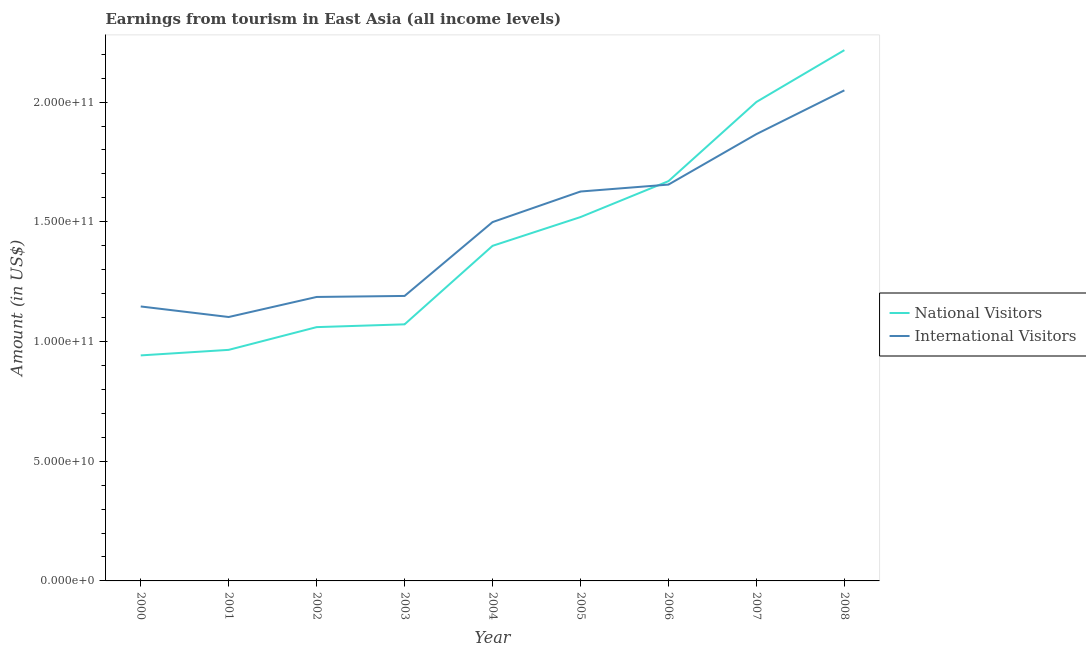How many different coloured lines are there?
Give a very brief answer. 2. Does the line corresponding to amount earned from international visitors intersect with the line corresponding to amount earned from national visitors?
Your answer should be compact. Yes. What is the amount earned from national visitors in 2006?
Make the answer very short. 1.67e+11. Across all years, what is the maximum amount earned from international visitors?
Your answer should be very brief. 2.05e+11. Across all years, what is the minimum amount earned from international visitors?
Give a very brief answer. 1.10e+11. In which year was the amount earned from international visitors minimum?
Offer a very short reply. 2001. What is the total amount earned from national visitors in the graph?
Ensure brevity in your answer.  1.28e+12. What is the difference between the amount earned from international visitors in 2005 and that in 2006?
Ensure brevity in your answer.  -2.89e+09. What is the difference between the amount earned from national visitors in 2000 and the amount earned from international visitors in 2001?
Your answer should be very brief. -1.60e+1. What is the average amount earned from international visitors per year?
Your answer should be compact. 1.48e+11. In the year 2006, what is the difference between the amount earned from national visitors and amount earned from international visitors?
Offer a terse response. 1.44e+09. In how many years, is the amount earned from national visitors greater than 200000000000 US$?
Your response must be concise. 2. What is the ratio of the amount earned from national visitors in 2002 to that in 2003?
Keep it short and to the point. 0.99. What is the difference between the highest and the second highest amount earned from national visitors?
Your response must be concise. 2.16e+1. What is the difference between the highest and the lowest amount earned from international visitors?
Give a very brief answer. 9.47e+1. In how many years, is the amount earned from international visitors greater than the average amount earned from international visitors taken over all years?
Your answer should be very brief. 5. Does the amount earned from international visitors monotonically increase over the years?
Offer a very short reply. No. Is the amount earned from national visitors strictly less than the amount earned from international visitors over the years?
Your answer should be very brief. No. How many lines are there?
Keep it short and to the point. 2. How many years are there in the graph?
Offer a terse response. 9. Does the graph contain grids?
Provide a succinct answer. No. Where does the legend appear in the graph?
Keep it short and to the point. Center right. How are the legend labels stacked?
Offer a terse response. Vertical. What is the title of the graph?
Make the answer very short. Earnings from tourism in East Asia (all income levels). Does "Techinal cooperation" appear as one of the legend labels in the graph?
Your answer should be compact. No. What is the label or title of the X-axis?
Offer a very short reply. Year. What is the Amount (in US$) in National Visitors in 2000?
Make the answer very short. 9.42e+1. What is the Amount (in US$) in International Visitors in 2000?
Offer a very short reply. 1.15e+11. What is the Amount (in US$) of National Visitors in 2001?
Offer a terse response. 9.65e+1. What is the Amount (in US$) in International Visitors in 2001?
Your answer should be compact. 1.10e+11. What is the Amount (in US$) in National Visitors in 2002?
Make the answer very short. 1.06e+11. What is the Amount (in US$) of International Visitors in 2002?
Your answer should be very brief. 1.19e+11. What is the Amount (in US$) of National Visitors in 2003?
Offer a terse response. 1.07e+11. What is the Amount (in US$) of International Visitors in 2003?
Keep it short and to the point. 1.19e+11. What is the Amount (in US$) in National Visitors in 2004?
Provide a succinct answer. 1.40e+11. What is the Amount (in US$) of International Visitors in 2004?
Your response must be concise. 1.50e+11. What is the Amount (in US$) of National Visitors in 2005?
Provide a short and direct response. 1.52e+11. What is the Amount (in US$) of International Visitors in 2005?
Give a very brief answer. 1.63e+11. What is the Amount (in US$) of National Visitors in 2006?
Your answer should be very brief. 1.67e+11. What is the Amount (in US$) of International Visitors in 2006?
Provide a short and direct response. 1.66e+11. What is the Amount (in US$) in National Visitors in 2007?
Offer a very short reply. 2.00e+11. What is the Amount (in US$) of International Visitors in 2007?
Ensure brevity in your answer.  1.87e+11. What is the Amount (in US$) of National Visitors in 2008?
Your answer should be very brief. 2.22e+11. What is the Amount (in US$) of International Visitors in 2008?
Provide a short and direct response. 2.05e+11. Across all years, what is the maximum Amount (in US$) of National Visitors?
Keep it short and to the point. 2.22e+11. Across all years, what is the maximum Amount (in US$) of International Visitors?
Your answer should be compact. 2.05e+11. Across all years, what is the minimum Amount (in US$) in National Visitors?
Your answer should be very brief. 9.42e+1. Across all years, what is the minimum Amount (in US$) in International Visitors?
Offer a terse response. 1.10e+11. What is the total Amount (in US$) of National Visitors in the graph?
Provide a succinct answer. 1.28e+12. What is the total Amount (in US$) of International Visitors in the graph?
Your answer should be very brief. 1.33e+12. What is the difference between the Amount (in US$) in National Visitors in 2000 and that in 2001?
Give a very brief answer. -2.31e+09. What is the difference between the Amount (in US$) in International Visitors in 2000 and that in 2001?
Provide a short and direct response. 4.40e+09. What is the difference between the Amount (in US$) in National Visitors in 2000 and that in 2002?
Your answer should be very brief. -1.18e+1. What is the difference between the Amount (in US$) of International Visitors in 2000 and that in 2002?
Your answer should be compact. -3.97e+09. What is the difference between the Amount (in US$) of National Visitors in 2000 and that in 2003?
Your answer should be very brief. -1.30e+1. What is the difference between the Amount (in US$) in International Visitors in 2000 and that in 2003?
Ensure brevity in your answer.  -4.40e+09. What is the difference between the Amount (in US$) in National Visitors in 2000 and that in 2004?
Keep it short and to the point. -4.58e+1. What is the difference between the Amount (in US$) in International Visitors in 2000 and that in 2004?
Provide a succinct answer. -3.52e+1. What is the difference between the Amount (in US$) in National Visitors in 2000 and that in 2005?
Ensure brevity in your answer.  -5.78e+1. What is the difference between the Amount (in US$) of International Visitors in 2000 and that in 2005?
Provide a short and direct response. -4.80e+1. What is the difference between the Amount (in US$) in National Visitors in 2000 and that in 2006?
Ensure brevity in your answer.  -7.28e+1. What is the difference between the Amount (in US$) of International Visitors in 2000 and that in 2006?
Make the answer very short. -5.09e+1. What is the difference between the Amount (in US$) in National Visitors in 2000 and that in 2007?
Provide a succinct answer. -1.06e+11. What is the difference between the Amount (in US$) of International Visitors in 2000 and that in 2007?
Offer a terse response. -7.20e+1. What is the difference between the Amount (in US$) in National Visitors in 2000 and that in 2008?
Provide a succinct answer. -1.27e+11. What is the difference between the Amount (in US$) of International Visitors in 2000 and that in 2008?
Provide a succinct answer. -9.03e+1. What is the difference between the Amount (in US$) in National Visitors in 2001 and that in 2002?
Provide a succinct answer. -9.50e+09. What is the difference between the Amount (in US$) in International Visitors in 2001 and that in 2002?
Make the answer very short. -8.38e+09. What is the difference between the Amount (in US$) in National Visitors in 2001 and that in 2003?
Your response must be concise. -1.07e+1. What is the difference between the Amount (in US$) of International Visitors in 2001 and that in 2003?
Ensure brevity in your answer.  -8.80e+09. What is the difference between the Amount (in US$) of National Visitors in 2001 and that in 2004?
Ensure brevity in your answer.  -4.35e+1. What is the difference between the Amount (in US$) of International Visitors in 2001 and that in 2004?
Give a very brief answer. -3.96e+1. What is the difference between the Amount (in US$) of National Visitors in 2001 and that in 2005?
Offer a terse response. -5.55e+1. What is the difference between the Amount (in US$) of International Visitors in 2001 and that in 2005?
Your answer should be compact. -5.24e+1. What is the difference between the Amount (in US$) of National Visitors in 2001 and that in 2006?
Your answer should be very brief. -7.05e+1. What is the difference between the Amount (in US$) of International Visitors in 2001 and that in 2006?
Keep it short and to the point. -5.53e+1. What is the difference between the Amount (in US$) of National Visitors in 2001 and that in 2007?
Make the answer very short. -1.04e+11. What is the difference between the Amount (in US$) of International Visitors in 2001 and that in 2007?
Your answer should be compact. -7.64e+1. What is the difference between the Amount (in US$) in National Visitors in 2001 and that in 2008?
Make the answer very short. -1.25e+11. What is the difference between the Amount (in US$) of International Visitors in 2001 and that in 2008?
Your answer should be very brief. -9.47e+1. What is the difference between the Amount (in US$) of National Visitors in 2002 and that in 2003?
Make the answer very short. -1.17e+09. What is the difference between the Amount (in US$) in International Visitors in 2002 and that in 2003?
Offer a terse response. -4.22e+08. What is the difference between the Amount (in US$) in National Visitors in 2002 and that in 2004?
Ensure brevity in your answer.  -3.40e+1. What is the difference between the Amount (in US$) of International Visitors in 2002 and that in 2004?
Keep it short and to the point. -3.13e+1. What is the difference between the Amount (in US$) of National Visitors in 2002 and that in 2005?
Give a very brief answer. -4.60e+1. What is the difference between the Amount (in US$) of International Visitors in 2002 and that in 2005?
Your answer should be compact. -4.40e+1. What is the difference between the Amount (in US$) in National Visitors in 2002 and that in 2006?
Keep it short and to the point. -6.10e+1. What is the difference between the Amount (in US$) in International Visitors in 2002 and that in 2006?
Make the answer very short. -4.69e+1. What is the difference between the Amount (in US$) of National Visitors in 2002 and that in 2007?
Ensure brevity in your answer.  -9.40e+1. What is the difference between the Amount (in US$) of International Visitors in 2002 and that in 2007?
Provide a short and direct response. -6.80e+1. What is the difference between the Amount (in US$) of National Visitors in 2002 and that in 2008?
Give a very brief answer. -1.16e+11. What is the difference between the Amount (in US$) of International Visitors in 2002 and that in 2008?
Give a very brief answer. -8.63e+1. What is the difference between the Amount (in US$) of National Visitors in 2003 and that in 2004?
Provide a short and direct response. -3.28e+1. What is the difference between the Amount (in US$) in International Visitors in 2003 and that in 2004?
Make the answer very short. -3.08e+1. What is the difference between the Amount (in US$) in National Visitors in 2003 and that in 2005?
Make the answer very short. -4.48e+1. What is the difference between the Amount (in US$) of International Visitors in 2003 and that in 2005?
Make the answer very short. -4.36e+1. What is the difference between the Amount (in US$) of National Visitors in 2003 and that in 2006?
Your response must be concise. -5.98e+1. What is the difference between the Amount (in US$) in International Visitors in 2003 and that in 2006?
Your response must be concise. -4.65e+1. What is the difference between the Amount (in US$) of National Visitors in 2003 and that in 2007?
Offer a very short reply. -9.29e+1. What is the difference between the Amount (in US$) of International Visitors in 2003 and that in 2007?
Offer a very short reply. -6.76e+1. What is the difference between the Amount (in US$) of National Visitors in 2003 and that in 2008?
Offer a terse response. -1.15e+11. What is the difference between the Amount (in US$) in International Visitors in 2003 and that in 2008?
Give a very brief answer. -8.59e+1. What is the difference between the Amount (in US$) of National Visitors in 2004 and that in 2005?
Offer a very short reply. -1.20e+1. What is the difference between the Amount (in US$) in International Visitors in 2004 and that in 2005?
Your answer should be compact. -1.28e+1. What is the difference between the Amount (in US$) of National Visitors in 2004 and that in 2006?
Make the answer very short. -2.70e+1. What is the difference between the Amount (in US$) of International Visitors in 2004 and that in 2006?
Your answer should be very brief. -1.57e+1. What is the difference between the Amount (in US$) of National Visitors in 2004 and that in 2007?
Make the answer very short. -6.01e+1. What is the difference between the Amount (in US$) in International Visitors in 2004 and that in 2007?
Offer a very short reply. -3.67e+1. What is the difference between the Amount (in US$) of National Visitors in 2004 and that in 2008?
Make the answer very short. -8.17e+1. What is the difference between the Amount (in US$) of International Visitors in 2004 and that in 2008?
Offer a terse response. -5.50e+1. What is the difference between the Amount (in US$) in National Visitors in 2005 and that in 2006?
Provide a succinct answer. -1.50e+1. What is the difference between the Amount (in US$) of International Visitors in 2005 and that in 2006?
Offer a very short reply. -2.89e+09. What is the difference between the Amount (in US$) of National Visitors in 2005 and that in 2007?
Your answer should be very brief. -4.81e+1. What is the difference between the Amount (in US$) of International Visitors in 2005 and that in 2007?
Your response must be concise. -2.40e+1. What is the difference between the Amount (in US$) of National Visitors in 2005 and that in 2008?
Keep it short and to the point. -6.97e+1. What is the difference between the Amount (in US$) in International Visitors in 2005 and that in 2008?
Offer a terse response. -4.23e+1. What is the difference between the Amount (in US$) in National Visitors in 2006 and that in 2007?
Make the answer very short. -3.31e+1. What is the difference between the Amount (in US$) in International Visitors in 2006 and that in 2007?
Provide a short and direct response. -2.11e+1. What is the difference between the Amount (in US$) of National Visitors in 2006 and that in 2008?
Keep it short and to the point. -5.47e+1. What is the difference between the Amount (in US$) of International Visitors in 2006 and that in 2008?
Your answer should be very brief. -3.94e+1. What is the difference between the Amount (in US$) in National Visitors in 2007 and that in 2008?
Provide a succinct answer. -2.16e+1. What is the difference between the Amount (in US$) in International Visitors in 2007 and that in 2008?
Offer a terse response. -1.83e+1. What is the difference between the Amount (in US$) of National Visitors in 2000 and the Amount (in US$) of International Visitors in 2001?
Give a very brief answer. -1.60e+1. What is the difference between the Amount (in US$) of National Visitors in 2000 and the Amount (in US$) of International Visitors in 2002?
Offer a terse response. -2.44e+1. What is the difference between the Amount (in US$) in National Visitors in 2000 and the Amount (in US$) in International Visitors in 2003?
Keep it short and to the point. -2.48e+1. What is the difference between the Amount (in US$) in National Visitors in 2000 and the Amount (in US$) in International Visitors in 2004?
Your response must be concise. -5.57e+1. What is the difference between the Amount (in US$) of National Visitors in 2000 and the Amount (in US$) of International Visitors in 2005?
Your response must be concise. -6.84e+1. What is the difference between the Amount (in US$) of National Visitors in 2000 and the Amount (in US$) of International Visitors in 2006?
Make the answer very short. -7.13e+1. What is the difference between the Amount (in US$) of National Visitors in 2000 and the Amount (in US$) of International Visitors in 2007?
Your answer should be very brief. -9.24e+1. What is the difference between the Amount (in US$) of National Visitors in 2000 and the Amount (in US$) of International Visitors in 2008?
Make the answer very short. -1.11e+11. What is the difference between the Amount (in US$) in National Visitors in 2001 and the Amount (in US$) in International Visitors in 2002?
Make the answer very short. -2.21e+1. What is the difference between the Amount (in US$) of National Visitors in 2001 and the Amount (in US$) of International Visitors in 2003?
Ensure brevity in your answer.  -2.25e+1. What is the difference between the Amount (in US$) in National Visitors in 2001 and the Amount (in US$) in International Visitors in 2004?
Provide a short and direct response. -5.34e+1. What is the difference between the Amount (in US$) in National Visitors in 2001 and the Amount (in US$) in International Visitors in 2005?
Offer a terse response. -6.61e+1. What is the difference between the Amount (in US$) in National Visitors in 2001 and the Amount (in US$) in International Visitors in 2006?
Offer a very short reply. -6.90e+1. What is the difference between the Amount (in US$) of National Visitors in 2001 and the Amount (in US$) of International Visitors in 2007?
Your answer should be compact. -9.01e+1. What is the difference between the Amount (in US$) in National Visitors in 2001 and the Amount (in US$) in International Visitors in 2008?
Your answer should be compact. -1.08e+11. What is the difference between the Amount (in US$) of National Visitors in 2002 and the Amount (in US$) of International Visitors in 2003?
Your response must be concise. -1.30e+1. What is the difference between the Amount (in US$) in National Visitors in 2002 and the Amount (in US$) in International Visitors in 2004?
Ensure brevity in your answer.  -4.39e+1. What is the difference between the Amount (in US$) in National Visitors in 2002 and the Amount (in US$) in International Visitors in 2005?
Your answer should be very brief. -5.66e+1. What is the difference between the Amount (in US$) of National Visitors in 2002 and the Amount (in US$) of International Visitors in 2006?
Provide a short and direct response. -5.95e+1. What is the difference between the Amount (in US$) of National Visitors in 2002 and the Amount (in US$) of International Visitors in 2007?
Your response must be concise. -8.06e+1. What is the difference between the Amount (in US$) of National Visitors in 2002 and the Amount (in US$) of International Visitors in 2008?
Ensure brevity in your answer.  -9.89e+1. What is the difference between the Amount (in US$) of National Visitors in 2003 and the Amount (in US$) of International Visitors in 2004?
Ensure brevity in your answer.  -4.27e+1. What is the difference between the Amount (in US$) of National Visitors in 2003 and the Amount (in US$) of International Visitors in 2005?
Keep it short and to the point. -5.55e+1. What is the difference between the Amount (in US$) of National Visitors in 2003 and the Amount (in US$) of International Visitors in 2006?
Provide a succinct answer. -5.84e+1. What is the difference between the Amount (in US$) of National Visitors in 2003 and the Amount (in US$) of International Visitors in 2007?
Your response must be concise. -7.94e+1. What is the difference between the Amount (in US$) of National Visitors in 2003 and the Amount (in US$) of International Visitors in 2008?
Provide a succinct answer. -9.77e+1. What is the difference between the Amount (in US$) in National Visitors in 2004 and the Amount (in US$) in International Visitors in 2005?
Give a very brief answer. -2.27e+1. What is the difference between the Amount (in US$) of National Visitors in 2004 and the Amount (in US$) of International Visitors in 2006?
Your answer should be compact. -2.56e+1. What is the difference between the Amount (in US$) of National Visitors in 2004 and the Amount (in US$) of International Visitors in 2007?
Make the answer very short. -4.67e+1. What is the difference between the Amount (in US$) of National Visitors in 2004 and the Amount (in US$) of International Visitors in 2008?
Provide a short and direct response. -6.49e+1. What is the difference between the Amount (in US$) in National Visitors in 2005 and the Amount (in US$) in International Visitors in 2006?
Provide a short and direct response. -1.36e+1. What is the difference between the Amount (in US$) of National Visitors in 2005 and the Amount (in US$) of International Visitors in 2007?
Your response must be concise. -3.47e+1. What is the difference between the Amount (in US$) in National Visitors in 2005 and the Amount (in US$) in International Visitors in 2008?
Provide a short and direct response. -5.29e+1. What is the difference between the Amount (in US$) in National Visitors in 2006 and the Amount (in US$) in International Visitors in 2007?
Provide a succinct answer. -1.96e+1. What is the difference between the Amount (in US$) in National Visitors in 2006 and the Amount (in US$) in International Visitors in 2008?
Provide a succinct answer. -3.79e+1. What is the difference between the Amount (in US$) of National Visitors in 2007 and the Amount (in US$) of International Visitors in 2008?
Provide a short and direct response. -4.85e+09. What is the average Amount (in US$) in National Visitors per year?
Give a very brief answer. 1.43e+11. What is the average Amount (in US$) of International Visitors per year?
Give a very brief answer. 1.48e+11. In the year 2000, what is the difference between the Amount (in US$) in National Visitors and Amount (in US$) in International Visitors?
Offer a terse response. -2.04e+1. In the year 2001, what is the difference between the Amount (in US$) of National Visitors and Amount (in US$) of International Visitors?
Give a very brief answer. -1.37e+1. In the year 2002, what is the difference between the Amount (in US$) of National Visitors and Amount (in US$) of International Visitors?
Keep it short and to the point. -1.26e+1. In the year 2003, what is the difference between the Amount (in US$) in National Visitors and Amount (in US$) in International Visitors?
Make the answer very short. -1.19e+1. In the year 2004, what is the difference between the Amount (in US$) in National Visitors and Amount (in US$) in International Visitors?
Offer a very short reply. -9.92e+09. In the year 2005, what is the difference between the Amount (in US$) in National Visitors and Amount (in US$) in International Visitors?
Your answer should be compact. -1.07e+1. In the year 2006, what is the difference between the Amount (in US$) of National Visitors and Amount (in US$) of International Visitors?
Offer a terse response. 1.44e+09. In the year 2007, what is the difference between the Amount (in US$) in National Visitors and Amount (in US$) in International Visitors?
Make the answer very short. 1.34e+1. In the year 2008, what is the difference between the Amount (in US$) of National Visitors and Amount (in US$) of International Visitors?
Provide a succinct answer. 1.68e+1. What is the ratio of the Amount (in US$) of National Visitors in 2000 to that in 2002?
Give a very brief answer. 0.89. What is the ratio of the Amount (in US$) of International Visitors in 2000 to that in 2002?
Give a very brief answer. 0.97. What is the ratio of the Amount (in US$) in National Visitors in 2000 to that in 2003?
Your response must be concise. 0.88. What is the ratio of the Amount (in US$) in International Visitors in 2000 to that in 2003?
Provide a short and direct response. 0.96. What is the ratio of the Amount (in US$) of National Visitors in 2000 to that in 2004?
Your response must be concise. 0.67. What is the ratio of the Amount (in US$) of International Visitors in 2000 to that in 2004?
Keep it short and to the point. 0.76. What is the ratio of the Amount (in US$) of National Visitors in 2000 to that in 2005?
Offer a very short reply. 0.62. What is the ratio of the Amount (in US$) in International Visitors in 2000 to that in 2005?
Offer a very short reply. 0.7. What is the ratio of the Amount (in US$) of National Visitors in 2000 to that in 2006?
Your answer should be very brief. 0.56. What is the ratio of the Amount (in US$) in International Visitors in 2000 to that in 2006?
Your answer should be very brief. 0.69. What is the ratio of the Amount (in US$) in National Visitors in 2000 to that in 2007?
Offer a terse response. 0.47. What is the ratio of the Amount (in US$) in International Visitors in 2000 to that in 2007?
Your response must be concise. 0.61. What is the ratio of the Amount (in US$) of National Visitors in 2000 to that in 2008?
Provide a succinct answer. 0.42. What is the ratio of the Amount (in US$) in International Visitors in 2000 to that in 2008?
Ensure brevity in your answer.  0.56. What is the ratio of the Amount (in US$) of National Visitors in 2001 to that in 2002?
Ensure brevity in your answer.  0.91. What is the ratio of the Amount (in US$) in International Visitors in 2001 to that in 2002?
Provide a succinct answer. 0.93. What is the ratio of the Amount (in US$) in National Visitors in 2001 to that in 2003?
Ensure brevity in your answer.  0.9. What is the ratio of the Amount (in US$) in International Visitors in 2001 to that in 2003?
Your answer should be compact. 0.93. What is the ratio of the Amount (in US$) of National Visitors in 2001 to that in 2004?
Provide a succinct answer. 0.69. What is the ratio of the Amount (in US$) in International Visitors in 2001 to that in 2004?
Your response must be concise. 0.74. What is the ratio of the Amount (in US$) of National Visitors in 2001 to that in 2005?
Offer a very short reply. 0.64. What is the ratio of the Amount (in US$) in International Visitors in 2001 to that in 2005?
Your answer should be very brief. 0.68. What is the ratio of the Amount (in US$) in National Visitors in 2001 to that in 2006?
Offer a terse response. 0.58. What is the ratio of the Amount (in US$) of International Visitors in 2001 to that in 2006?
Make the answer very short. 0.67. What is the ratio of the Amount (in US$) of National Visitors in 2001 to that in 2007?
Ensure brevity in your answer.  0.48. What is the ratio of the Amount (in US$) in International Visitors in 2001 to that in 2007?
Provide a short and direct response. 0.59. What is the ratio of the Amount (in US$) of National Visitors in 2001 to that in 2008?
Offer a very short reply. 0.44. What is the ratio of the Amount (in US$) of International Visitors in 2001 to that in 2008?
Provide a short and direct response. 0.54. What is the ratio of the Amount (in US$) of National Visitors in 2002 to that in 2003?
Your answer should be very brief. 0.99. What is the ratio of the Amount (in US$) in International Visitors in 2002 to that in 2003?
Offer a terse response. 1. What is the ratio of the Amount (in US$) of National Visitors in 2002 to that in 2004?
Provide a short and direct response. 0.76. What is the ratio of the Amount (in US$) in International Visitors in 2002 to that in 2004?
Make the answer very short. 0.79. What is the ratio of the Amount (in US$) in National Visitors in 2002 to that in 2005?
Your response must be concise. 0.7. What is the ratio of the Amount (in US$) of International Visitors in 2002 to that in 2005?
Ensure brevity in your answer.  0.73. What is the ratio of the Amount (in US$) in National Visitors in 2002 to that in 2006?
Provide a short and direct response. 0.63. What is the ratio of the Amount (in US$) of International Visitors in 2002 to that in 2006?
Provide a succinct answer. 0.72. What is the ratio of the Amount (in US$) of National Visitors in 2002 to that in 2007?
Ensure brevity in your answer.  0.53. What is the ratio of the Amount (in US$) of International Visitors in 2002 to that in 2007?
Make the answer very short. 0.64. What is the ratio of the Amount (in US$) in National Visitors in 2002 to that in 2008?
Your response must be concise. 0.48. What is the ratio of the Amount (in US$) in International Visitors in 2002 to that in 2008?
Offer a very short reply. 0.58. What is the ratio of the Amount (in US$) in National Visitors in 2003 to that in 2004?
Give a very brief answer. 0.77. What is the ratio of the Amount (in US$) in International Visitors in 2003 to that in 2004?
Provide a short and direct response. 0.79. What is the ratio of the Amount (in US$) in National Visitors in 2003 to that in 2005?
Your answer should be compact. 0.71. What is the ratio of the Amount (in US$) in International Visitors in 2003 to that in 2005?
Give a very brief answer. 0.73. What is the ratio of the Amount (in US$) of National Visitors in 2003 to that in 2006?
Your answer should be compact. 0.64. What is the ratio of the Amount (in US$) of International Visitors in 2003 to that in 2006?
Your answer should be very brief. 0.72. What is the ratio of the Amount (in US$) of National Visitors in 2003 to that in 2007?
Your response must be concise. 0.54. What is the ratio of the Amount (in US$) of International Visitors in 2003 to that in 2007?
Offer a terse response. 0.64. What is the ratio of the Amount (in US$) of National Visitors in 2003 to that in 2008?
Your answer should be compact. 0.48. What is the ratio of the Amount (in US$) in International Visitors in 2003 to that in 2008?
Ensure brevity in your answer.  0.58. What is the ratio of the Amount (in US$) in National Visitors in 2004 to that in 2005?
Provide a succinct answer. 0.92. What is the ratio of the Amount (in US$) of International Visitors in 2004 to that in 2005?
Offer a very short reply. 0.92. What is the ratio of the Amount (in US$) in National Visitors in 2004 to that in 2006?
Provide a short and direct response. 0.84. What is the ratio of the Amount (in US$) of International Visitors in 2004 to that in 2006?
Provide a succinct answer. 0.91. What is the ratio of the Amount (in US$) of National Visitors in 2004 to that in 2007?
Offer a very short reply. 0.7. What is the ratio of the Amount (in US$) of International Visitors in 2004 to that in 2007?
Make the answer very short. 0.8. What is the ratio of the Amount (in US$) of National Visitors in 2004 to that in 2008?
Offer a terse response. 0.63. What is the ratio of the Amount (in US$) of International Visitors in 2004 to that in 2008?
Keep it short and to the point. 0.73. What is the ratio of the Amount (in US$) in National Visitors in 2005 to that in 2006?
Your answer should be compact. 0.91. What is the ratio of the Amount (in US$) in International Visitors in 2005 to that in 2006?
Ensure brevity in your answer.  0.98. What is the ratio of the Amount (in US$) of National Visitors in 2005 to that in 2007?
Give a very brief answer. 0.76. What is the ratio of the Amount (in US$) in International Visitors in 2005 to that in 2007?
Keep it short and to the point. 0.87. What is the ratio of the Amount (in US$) of National Visitors in 2005 to that in 2008?
Your answer should be very brief. 0.69. What is the ratio of the Amount (in US$) of International Visitors in 2005 to that in 2008?
Offer a terse response. 0.79. What is the ratio of the Amount (in US$) of National Visitors in 2006 to that in 2007?
Offer a terse response. 0.83. What is the ratio of the Amount (in US$) in International Visitors in 2006 to that in 2007?
Your answer should be very brief. 0.89. What is the ratio of the Amount (in US$) in National Visitors in 2006 to that in 2008?
Make the answer very short. 0.75. What is the ratio of the Amount (in US$) of International Visitors in 2006 to that in 2008?
Provide a succinct answer. 0.81. What is the ratio of the Amount (in US$) in National Visitors in 2007 to that in 2008?
Offer a very short reply. 0.9. What is the ratio of the Amount (in US$) of International Visitors in 2007 to that in 2008?
Your answer should be very brief. 0.91. What is the difference between the highest and the second highest Amount (in US$) of National Visitors?
Your response must be concise. 2.16e+1. What is the difference between the highest and the second highest Amount (in US$) of International Visitors?
Make the answer very short. 1.83e+1. What is the difference between the highest and the lowest Amount (in US$) in National Visitors?
Keep it short and to the point. 1.27e+11. What is the difference between the highest and the lowest Amount (in US$) of International Visitors?
Your answer should be compact. 9.47e+1. 